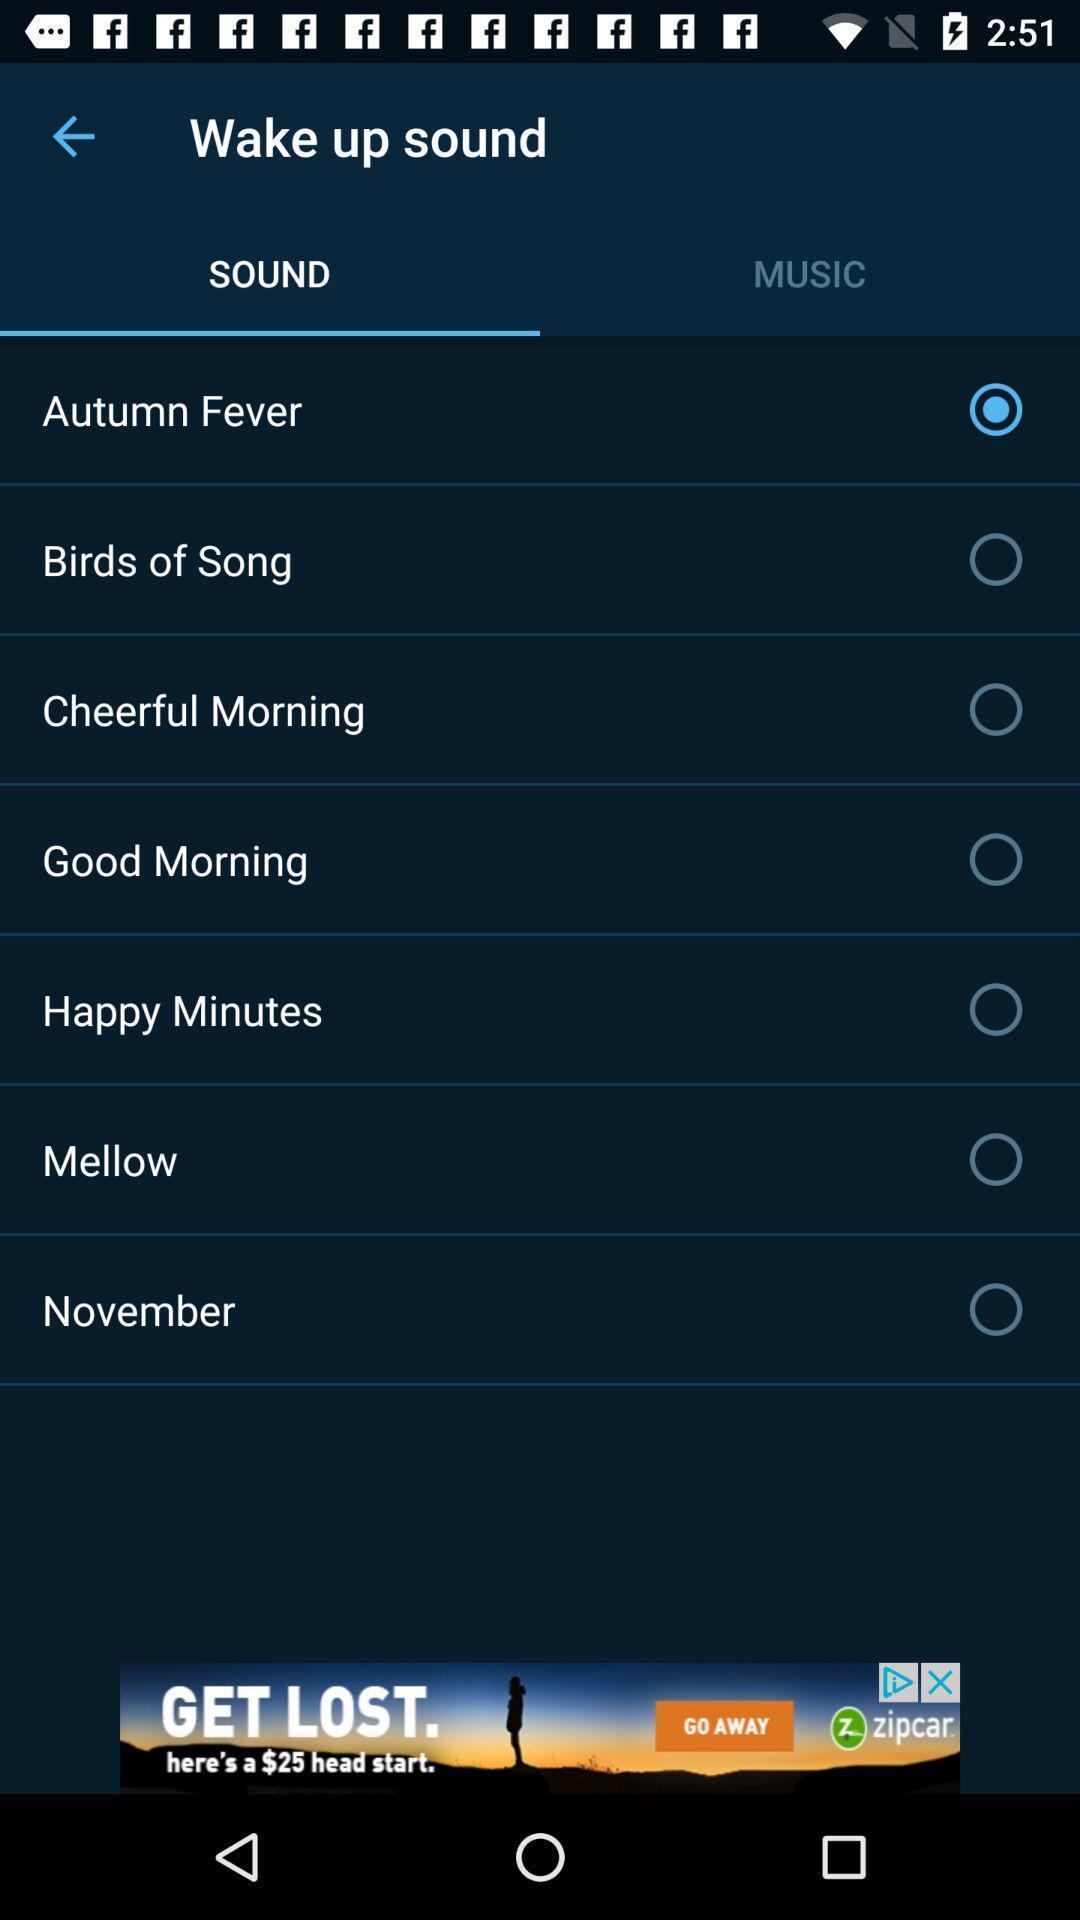Provide a textual representation of this image. Page displaying the list of different sounds. 